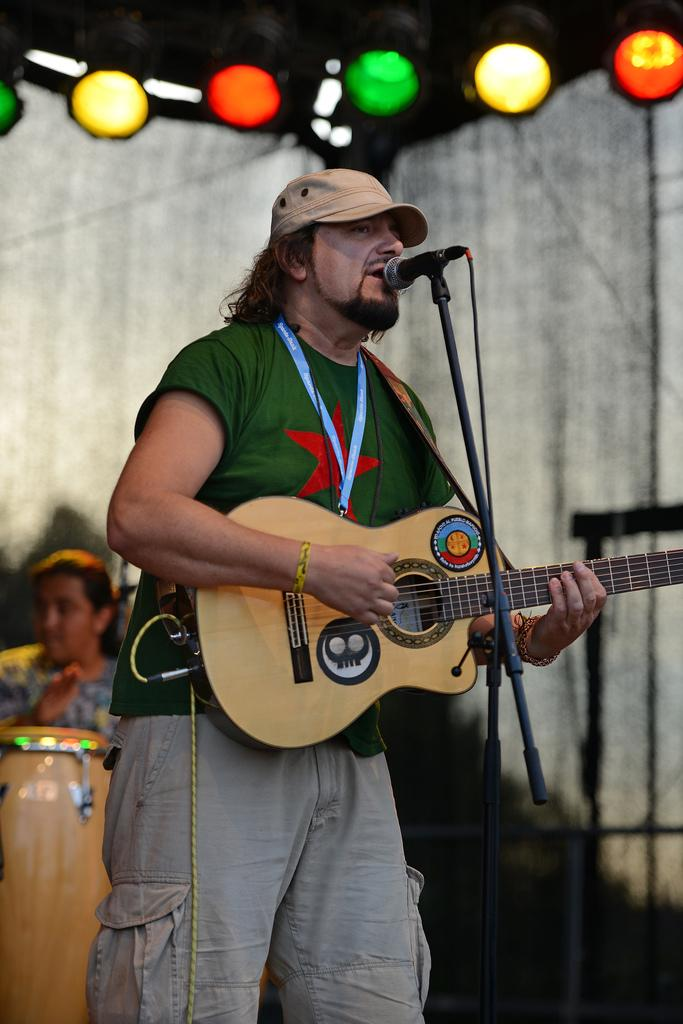What is the man in the image holding? The man is holding a guitar. What is the man doing with the guitar? The man is playing the guitar. What is the man doing while playing the guitar? The man is singing on a microphone. Can you describe the background of the image? There is a person, a wall, lights, and drums in the background of the image. What type of suit is the man wearing in the image? There is no suit visible in the image; the man is wearing a shirt and holding a guitar. Can you tell me how many pencils are on the drums in the image? There are no pencils present in the image; the drums are visible in the background, but no writing instruments are mentioned or depicted. 